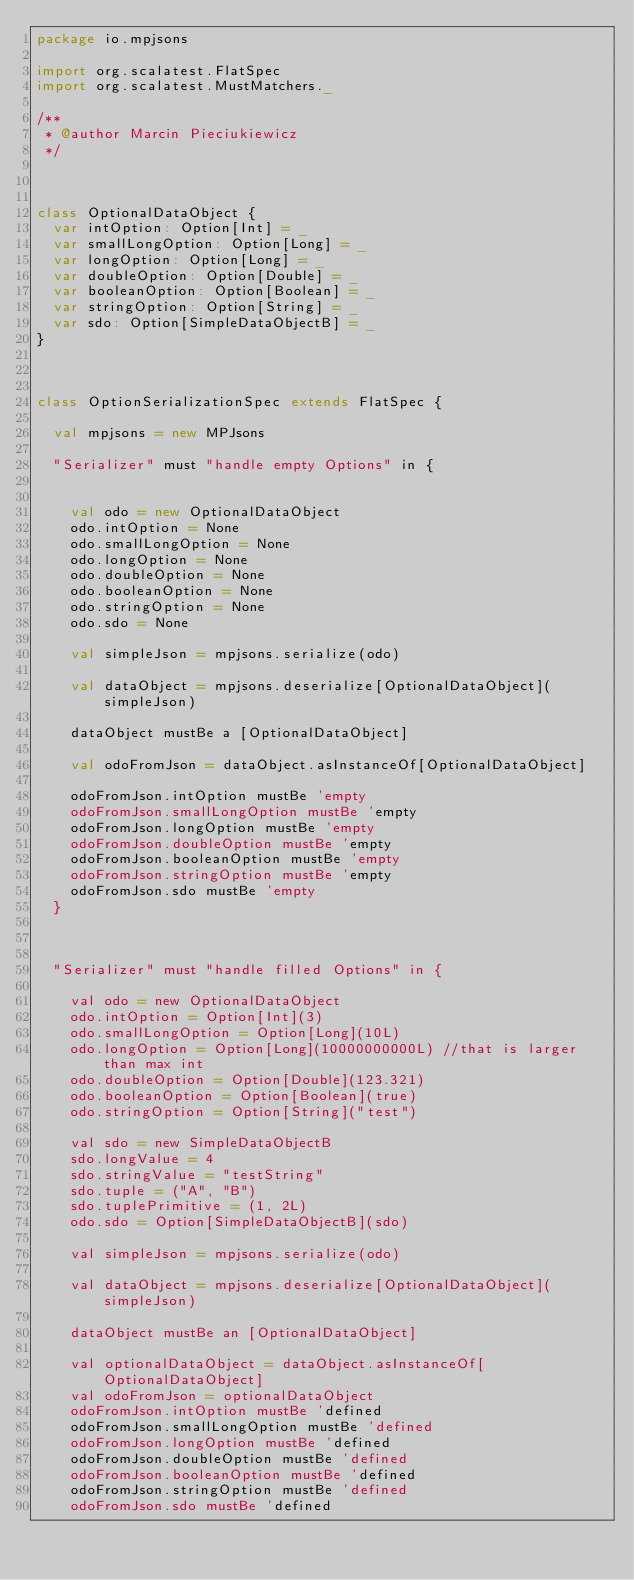Convert code to text. <code><loc_0><loc_0><loc_500><loc_500><_Scala_>package io.mpjsons

import org.scalatest.FlatSpec
import org.scalatest.MustMatchers._

/**
 * @author Marcin Pieciukiewicz
 */



class OptionalDataObject {
  var intOption: Option[Int] = _
  var smallLongOption: Option[Long] = _
  var longOption: Option[Long] = _
  var doubleOption: Option[Double] = _
  var booleanOption: Option[Boolean] = _
  var stringOption: Option[String] = _
  var sdo: Option[SimpleDataObjectB] = _
}



class OptionSerializationSpec extends FlatSpec {

  val mpjsons = new MPJsons

  "Serializer" must "handle empty Options" in {


    val odo = new OptionalDataObject
    odo.intOption = None
    odo.smallLongOption = None
    odo.longOption = None
    odo.doubleOption = None
    odo.booleanOption = None
    odo.stringOption = None
    odo.sdo = None

    val simpleJson = mpjsons.serialize(odo)

    val dataObject = mpjsons.deserialize[OptionalDataObject](simpleJson)

    dataObject mustBe a [OptionalDataObject]

    val odoFromJson = dataObject.asInstanceOf[OptionalDataObject]

    odoFromJson.intOption mustBe 'empty
    odoFromJson.smallLongOption mustBe 'empty
    odoFromJson.longOption mustBe 'empty
    odoFromJson.doubleOption mustBe 'empty
    odoFromJson.booleanOption mustBe 'empty
    odoFromJson.stringOption mustBe 'empty
    odoFromJson.sdo mustBe 'empty
  }



  "Serializer" must "handle filled Options" in {

    val odo = new OptionalDataObject
    odo.intOption = Option[Int](3)
    odo.smallLongOption = Option[Long](10L)
    odo.longOption = Option[Long](10000000000L) //that is larger than max int
    odo.doubleOption = Option[Double](123.321)
    odo.booleanOption = Option[Boolean](true)
    odo.stringOption = Option[String]("test")

    val sdo = new SimpleDataObjectB
    sdo.longValue = 4
    sdo.stringValue = "testString"
    sdo.tuple = ("A", "B")
    sdo.tuplePrimitive = (1, 2L)
    odo.sdo = Option[SimpleDataObjectB](sdo)

    val simpleJson = mpjsons.serialize(odo)

    val dataObject = mpjsons.deserialize[OptionalDataObject](simpleJson)

    dataObject mustBe an [OptionalDataObject]

    val optionalDataObject = dataObject.asInstanceOf[OptionalDataObject]
    val odoFromJson = optionalDataObject
    odoFromJson.intOption mustBe 'defined
    odoFromJson.smallLongOption mustBe 'defined
    odoFromJson.longOption mustBe 'defined
    odoFromJson.doubleOption mustBe 'defined
    odoFromJson.booleanOption mustBe 'defined
    odoFromJson.stringOption mustBe 'defined
    odoFromJson.sdo mustBe 'defined</code> 